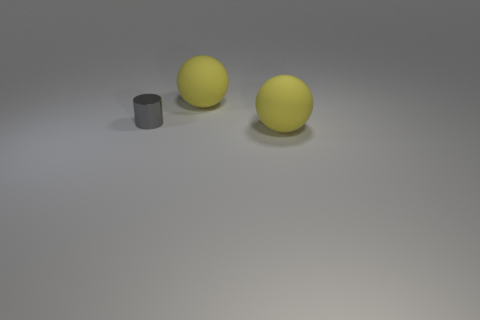There is a large matte ball that is behind the metallic cylinder; what is its color?
Your answer should be very brief. Yellow. The big sphere that is right of the ball that is behind the gray shiny cylinder is made of what material?
Your answer should be compact. Rubber. What number of green objects are matte objects or metallic cylinders?
Provide a short and direct response. 0. Are there an equal number of large yellow matte things on the right side of the tiny gray object and big red blocks?
Ensure brevity in your answer.  No. How many objects are either gray shiny cylinders or large objects that are on the right side of the metallic object?
Your response must be concise. 3. Are there any other small things that have the same material as the gray thing?
Your answer should be compact. No. Do the cylinder and the yellow ball behind the gray metal thing have the same material?
Keep it short and to the point. No. There is a big rubber object behind the big rubber sphere that is in front of the small gray metal object; what is its shape?
Your response must be concise. Sphere. Is the size of the matte ball that is in front of the gray cylinder the same as the small gray thing?
Your answer should be very brief. No. What number of other things are there of the same shape as the tiny thing?
Your answer should be compact. 0. 